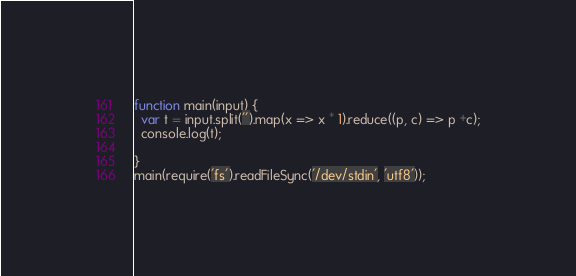<code> <loc_0><loc_0><loc_500><loc_500><_JavaScript_>function main(input) {
  var t = input.split('').map(x => x * 1).reduce((p, c) => p +c);
  console.log(t);
  
}
main(require('fs').readFileSync('/dev/stdin', 'utf8'));</code> 